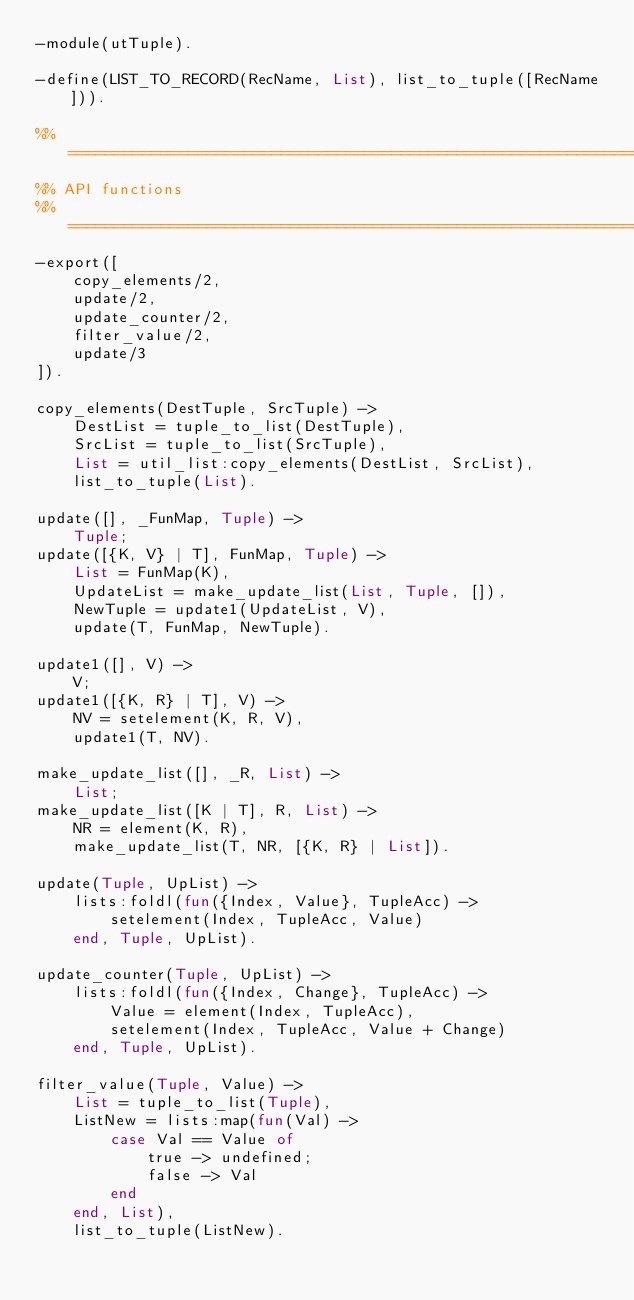Convert code to text. <code><loc_0><loc_0><loc_500><loc_500><_Erlang_>-module(utTuple).

-define(LIST_TO_RECORD(RecName, List), list_to_tuple([RecName])).

%% ====================================================================
%% API functions
%% ====================================================================
-export([
	copy_elements/2,
	update/2,
	update_counter/2,
	filter_value/2,
	update/3
]).

copy_elements(DestTuple, SrcTuple) ->
	DestList = tuple_to_list(DestTuple),
	SrcList = tuple_to_list(SrcTuple),
	List = util_list:copy_elements(DestList, SrcList),
	list_to_tuple(List).

update([], _FunMap, Tuple) ->
	Tuple;
update([{K, V} | T], FunMap, Tuple) ->
	List = FunMap(K),
	UpdateList = make_update_list(List, Tuple, []),
	NewTuple = update1(UpdateList, V),
	update(T, FunMap, NewTuple).

update1([], V) ->
	V;
update1([{K, R} | T], V) ->
	NV = setelement(K, R, V),
	update1(T, NV).

make_update_list([], _R, List) ->
	List;
make_update_list([K | T], R, List) ->
	NR = element(K, R),
	make_update_list(T, NR, [{K, R} | List]).

update(Tuple, UpList) ->
	lists:foldl(fun({Index, Value}, TupleAcc) ->
		setelement(Index, TupleAcc, Value)
	end, Tuple, UpList).

update_counter(Tuple, UpList) ->
	lists:foldl(fun({Index, Change}, TupleAcc) ->
		Value = element(Index, TupleAcc),
		setelement(Index, TupleAcc, Value + Change)
	end, Tuple, UpList).

filter_value(Tuple, Value) ->
	List = tuple_to_list(Tuple),
	ListNew = lists:map(fun(Val) ->
		case Val == Value of
			true -> undefined;
			false -> Val
		end
	end, List),
	list_to_tuple(ListNew).

</code> 